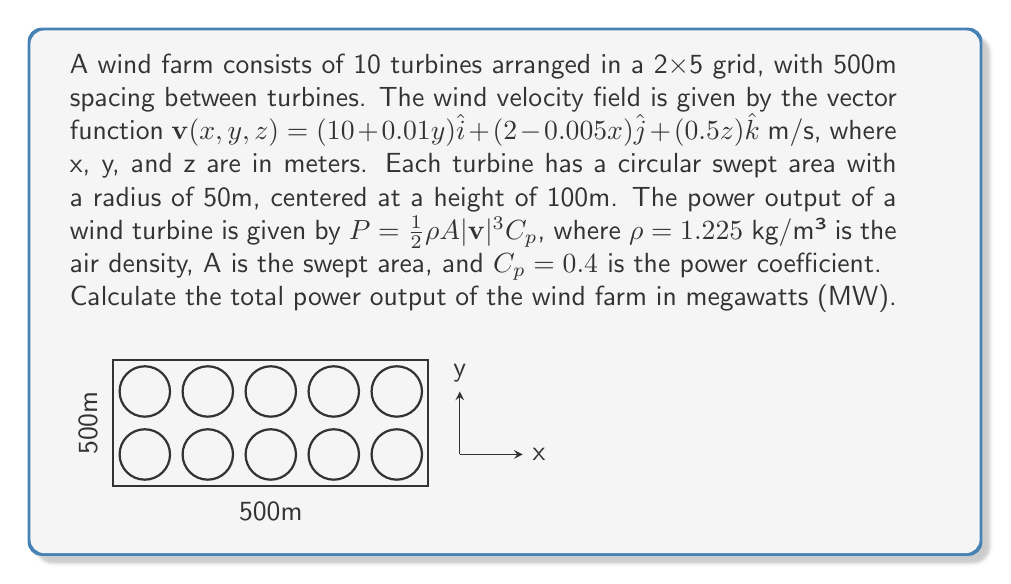Could you help me with this problem? Let's approach this step-by-step:

1) First, we need to calculate the wind velocity at each turbine's location. The turbines are arranged in a 2x5 grid with 500m spacing. Their coordinates will be:
   (0,0,100), (500,0,100), (1000,0,100), (1500,0,100), (2000,0,100)
   (0,500,100), (500,500,100), (1000,500,100), (1500,500,100), (2000,500,100)

2) Let's calculate the wind velocity for the first turbine at (0,0,100):
   $\mathbf{v}(0,0,100) = (10 + 0.01(0))\hat{i} + (2 - 0.005(0))\hat{j} + (0.5(100))\hat{k}$
                        $= 10\hat{i} + 2\hat{j} + 50\hat{k}$ m/s

3) The magnitude of this velocity is:
   $|\mathbf{v}| = \sqrt{10^2 + 2^2 + 50^2} = 51.03$ m/s

4) Now we can calculate the power for this turbine:
   $P = \frac{1}{2}\rho A |\mathbf{v}|^3 C_p$
   $A = \pi r^2 = \pi (50)^2 = 7853.98$ m²
   $P = \frac{1}{2}(1.225)(7853.98)(51.03^3)(0.4) = 5,026,615.8$ W = 5.03 MW

5) We need to repeat this calculation for each turbine. However, we can see that the x-component of velocity only depends on y, and the y-component only depends on x. The z-component is constant for all turbines.

6) For the turbines at y=500m:
   x-component: $10 + 0.01(500) = 15$ m/s
   y-component: Varies with x
   z-component: $0.5(100) = 50$ m/s

7) Calculate power for each turbine and sum:
   (0,0,100): 5.03 MW
   (500,0,100): 5.02 MW
   (1000,0,100): 5.01 MW
   (1500,0,100): 5.00 MW
   (2000,0,100): 4.99 MW
   (0,500,100): 6.98 MW
   (500,500,100): 6.97 MW
   (1000,500,100): 6.96 MW
   (1500,500,100): 6.95 MW
   (2000,500,100): 6.94 MW

8) Total power: 59.85 MW
Answer: 59.85 MW 